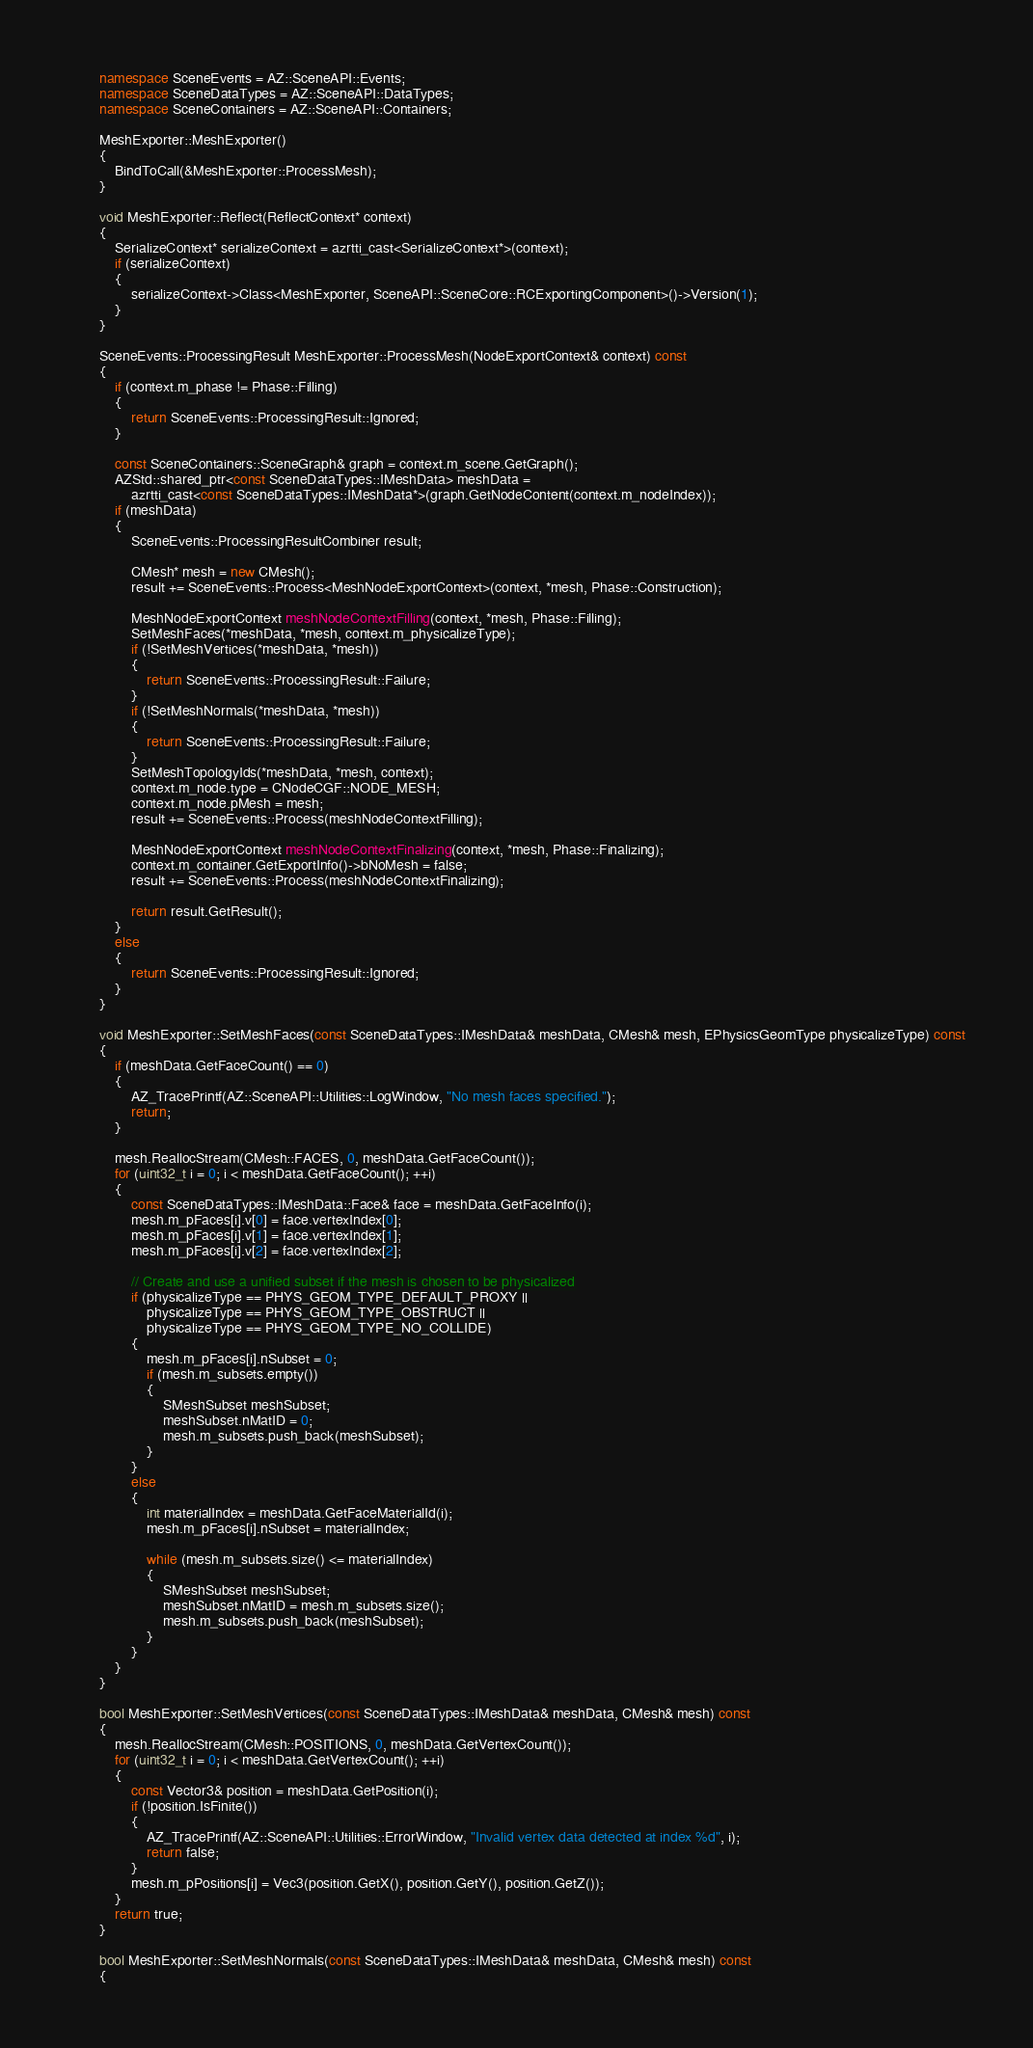Convert code to text. <code><loc_0><loc_0><loc_500><loc_500><_C++_>        namespace SceneEvents = AZ::SceneAPI::Events;
        namespace SceneDataTypes = AZ::SceneAPI::DataTypes;
        namespace SceneContainers = AZ::SceneAPI::Containers;

        MeshExporter::MeshExporter()
        {
            BindToCall(&MeshExporter::ProcessMesh);
        }

        void MeshExporter::Reflect(ReflectContext* context)
        {
            SerializeContext* serializeContext = azrtti_cast<SerializeContext*>(context);
            if (serializeContext)
            {
                serializeContext->Class<MeshExporter, SceneAPI::SceneCore::RCExportingComponent>()->Version(1);
            }
        }

        SceneEvents::ProcessingResult MeshExporter::ProcessMesh(NodeExportContext& context) const
        {
            if (context.m_phase != Phase::Filling)
            {
                return SceneEvents::ProcessingResult::Ignored;
            }

            const SceneContainers::SceneGraph& graph = context.m_scene.GetGraph();
            AZStd::shared_ptr<const SceneDataTypes::IMeshData> meshData = 
                azrtti_cast<const SceneDataTypes::IMeshData*>(graph.GetNodeContent(context.m_nodeIndex));
            if (meshData)
            {
                SceneEvents::ProcessingResultCombiner result;

                CMesh* mesh = new CMesh();
                result += SceneEvents::Process<MeshNodeExportContext>(context, *mesh, Phase::Construction);

                MeshNodeExportContext meshNodeContextFilling(context, *mesh, Phase::Filling);
                SetMeshFaces(*meshData, *mesh, context.m_physicalizeType);
                if (!SetMeshVertices(*meshData, *mesh))
                {
                    return SceneEvents::ProcessingResult::Failure;
                }
                if (!SetMeshNormals(*meshData, *mesh))
                {
                    return SceneEvents::ProcessingResult::Failure;
                }
                SetMeshTopologyIds(*meshData, *mesh, context);
                context.m_node.type = CNodeCGF::NODE_MESH;
                context.m_node.pMesh = mesh;
                result += SceneEvents::Process(meshNodeContextFilling);

                MeshNodeExportContext meshNodeContextFinalizing(context, *mesh, Phase::Finalizing);
                context.m_container.GetExportInfo()->bNoMesh = false;
                result += SceneEvents::Process(meshNodeContextFinalizing);
                
                return result.GetResult();
            }
            else
            {
                return SceneEvents::ProcessingResult::Ignored;
            }
        }

        void MeshExporter::SetMeshFaces(const SceneDataTypes::IMeshData& meshData, CMesh& mesh, EPhysicsGeomType physicalizeType) const
        {
            if (meshData.GetFaceCount() == 0)
            {
                AZ_TracePrintf(AZ::SceneAPI::Utilities::LogWindow, "No mesh faces specified.");
                return;
            }

            mesh.ReallocStream(CMesh::FACES, 0, meshData.GetFaceCount());
            for (uint32_t i = 0; i < meshData.GetFaceCount(); ++i)
            {
                const SceneDataTypes::IMeshData::Face& face = meshData.GetFaceInfo(i);
                mesh.m_pFaces[i].v[0] = face.vertexIndex[0];
                mesh.m_pFaces[i].v[1] = face.vertexIndex[1];
                mesh.m_pFaces[i].v[2] = face.vertexIndex[2];

                // Create and use a unified subset if the mesh is chosen to be physicalized
                if (physicalizeType == PHYS_GEOM_TYPE_DEFAULT_PROXY ||
                    physicalizeType == PHYS_GEOM_TYPE_OBSTRUCT ||
                    physicalizeType == PHYS_GEOM_TYPE_NO_COLLIDE)
                {
                    mesh.m_pFaces[i].nSubset = 0;
                    if (mesh.m_subsets.empty())
                    {
                        SMeshSubset meshSubset;
                        meshSubset.nMatID = 0;
                        mesh.m_subsets.push_back(meshSubset);
                    }
                }
                else
                {
                    int materialIndex = meshData.GetFaceMaterialId(i);
                    mesh.m_pFaces[i].nSubset = materialIndex;

                    while (mesh.m_subsets.size() <= materialIndex)
                    {
                        SMeshSubset meshSubset;
                        meshSubset.nMatID = mesh.m_subsets.size();
                        mesh.m_subsets.push_back(meshSubset);
                    }
                }
            }
        }

        bool MeshExporter::SetMeshVertices(const SceneDataTypes::IMeshData& meshData, CMesh& mesh) const
        {
            mesh.ReallocStream(CMesh::POSITIONS, 0, meshData.GetVertexCount());
            for (uint32_t i = 0; i < meshData.GetVertexCount(); ++i)
            {
                const Vector3& position = meshData.GetPosition(i);
                if (!position.IsFinite())
                {
                    AZ_TracePrintf(AZ::SceneAPI::Utilities::ErrorWindow, "Invalid vertex data detected at index %d", i);
                    return false;
                }
                mesh.m_pPositions[i] = Vec3(position.GetX(), position.GetY(), position.GetZ());
            }
            return true;
        }

        bool MeshExporter::SetMeshNormals(const SceneDataTypes::IMeshData& meshData, CMesh& mesh) const
        {</code> 